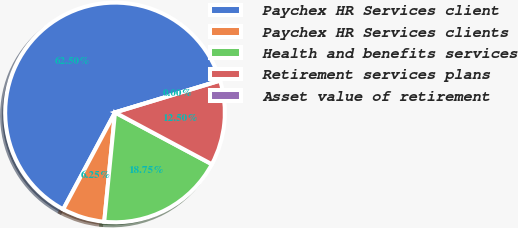Convert chart. <chart><loc_0><loc_0><loc_500><loc_500><pie_chart><fcel>Paychex HR Services client<fcel>Paychex HR Services clients<fcel>Health and benefits services<fcel>Retirement services plans<fcel>Asset value of retirement<nl><fcel>62.5%<fcel>6.25%<fcel>18.75%<fcel>12.5%<fcel>0.0%<nl></chart> 